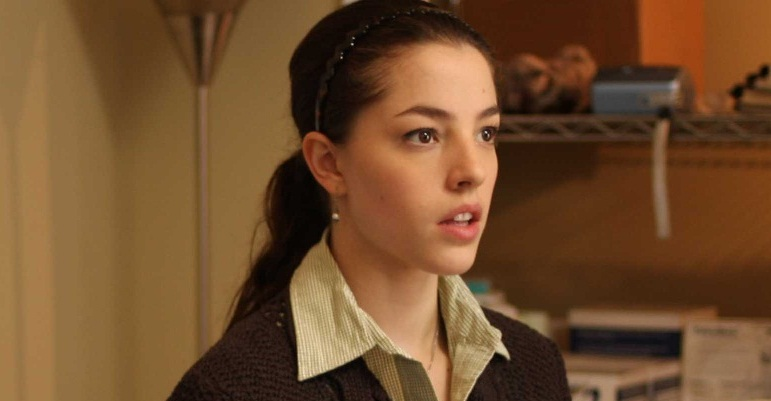If the woman in the image were a character in a film, what kind of film might it be and what role would she play? Be very creative. If the woman in the image were a character in a film, it might be an indie drama or a psychological thriller of intricate depth and subtle intensity. Perhaps it's a story set in a small town with secrets lurking beneath its tranquil surface. She could play the role of a young investigative journalist or an amateur sleuth uncovering the hidden truths of a seemingly idyllic community. Her serious and thoughtful demeanor suggests she has a keen intellect and a knack for noticing the details others miss. As the plot unfolds, we might see her unravel layers of deception, piecing together clues with a relentless dedication that echoes the intense focus captured in this moment. 